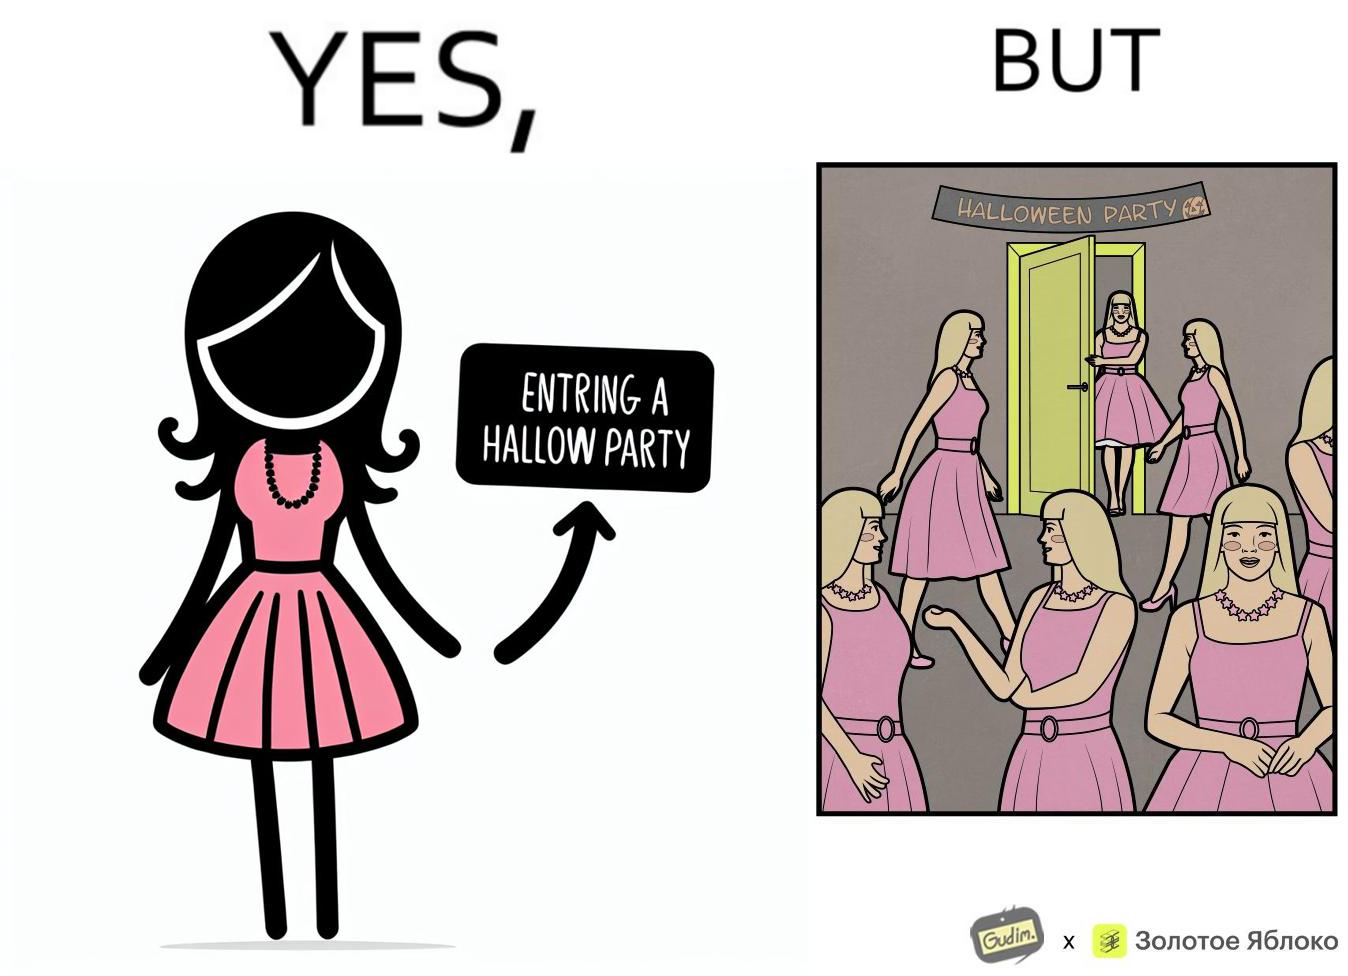Describe the satirical element in this image. The image is funny, as the person entering the Halloween Party has a costume that is identical to many other people in the party. 